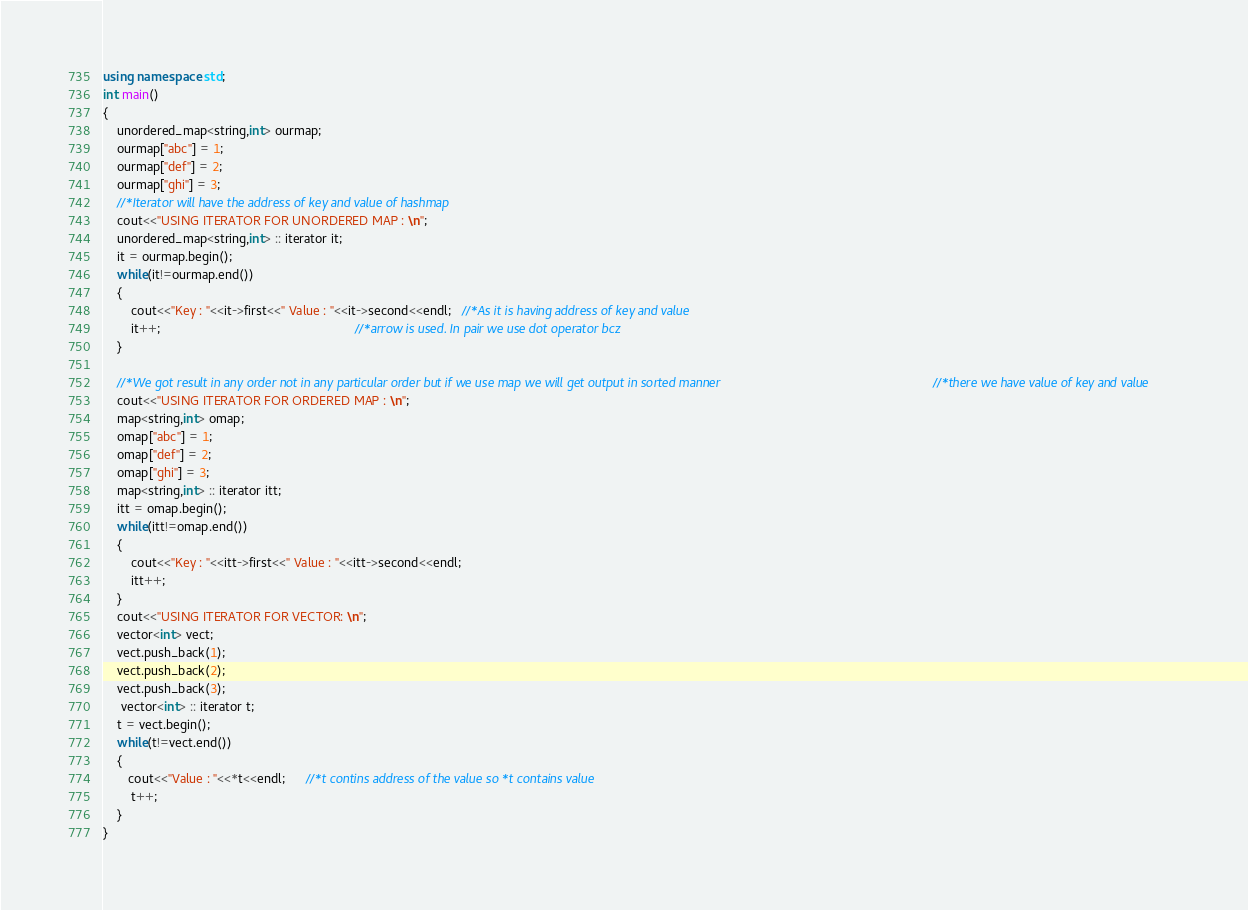<code> <loc_0><loc_0><loc_500><loc_500><_C++_>using namespace std;
int main()
{
    unordered_map<string,int> ourmap;
    ourmap["abc"] = 1;
    ourmap["def"] = 2;
    ourmap["ghi"] = 3;
    //*Iterator will have the address of key and value of hashmap
    cout<<"USING ITERATOR FOR UNORDERED MAP : \n";
    unordered_map<string,int> :: iterator it;
    it = ourmap.begin();
    while(it!=ourmap.end())
    {
        cout<<"Key : "<<it->first<<" Value : "<<it->second<<endl;   //*As it is having address of key and value
        it++;                                                       //*arrow is used. In pair we use dot operator bcz
    }   
    
    //*We got result in any order not in any particular order but if we use map we will get output in sorted manner                                                            //*there we have value of key and value
    cout<<"USING ITERATOR FOR ORDERED MAP : \n";
    map<string,int> omap;
    omap["abc"] = 1;
    omap["def"] = 2;
    omap["ghi"] = 3;
    map<string,int> :: iterator itt;
    itt = omap.begin();
    while(itt!=omap.end())
    {
        cout<<"Key : "<<itt->first<<" Value : "<<itt->second<<endl;   
        itt++;                                                       
    }     
    cout<<"USING ITERATOR FOR VECTOR: \n";
    vector<int> vect;
    vect.push_back(1);
    vect.push_back(2);
    vect.push_back(3);
     vector<int> :: iterator t;
    t = vect.begin();
    while(t!=vect.end())
    {
       cout<<"Value : "<<*t<<endl;      //*t contins address of the value so *t contains value
        t++;                                                       
    }     
}</code> 